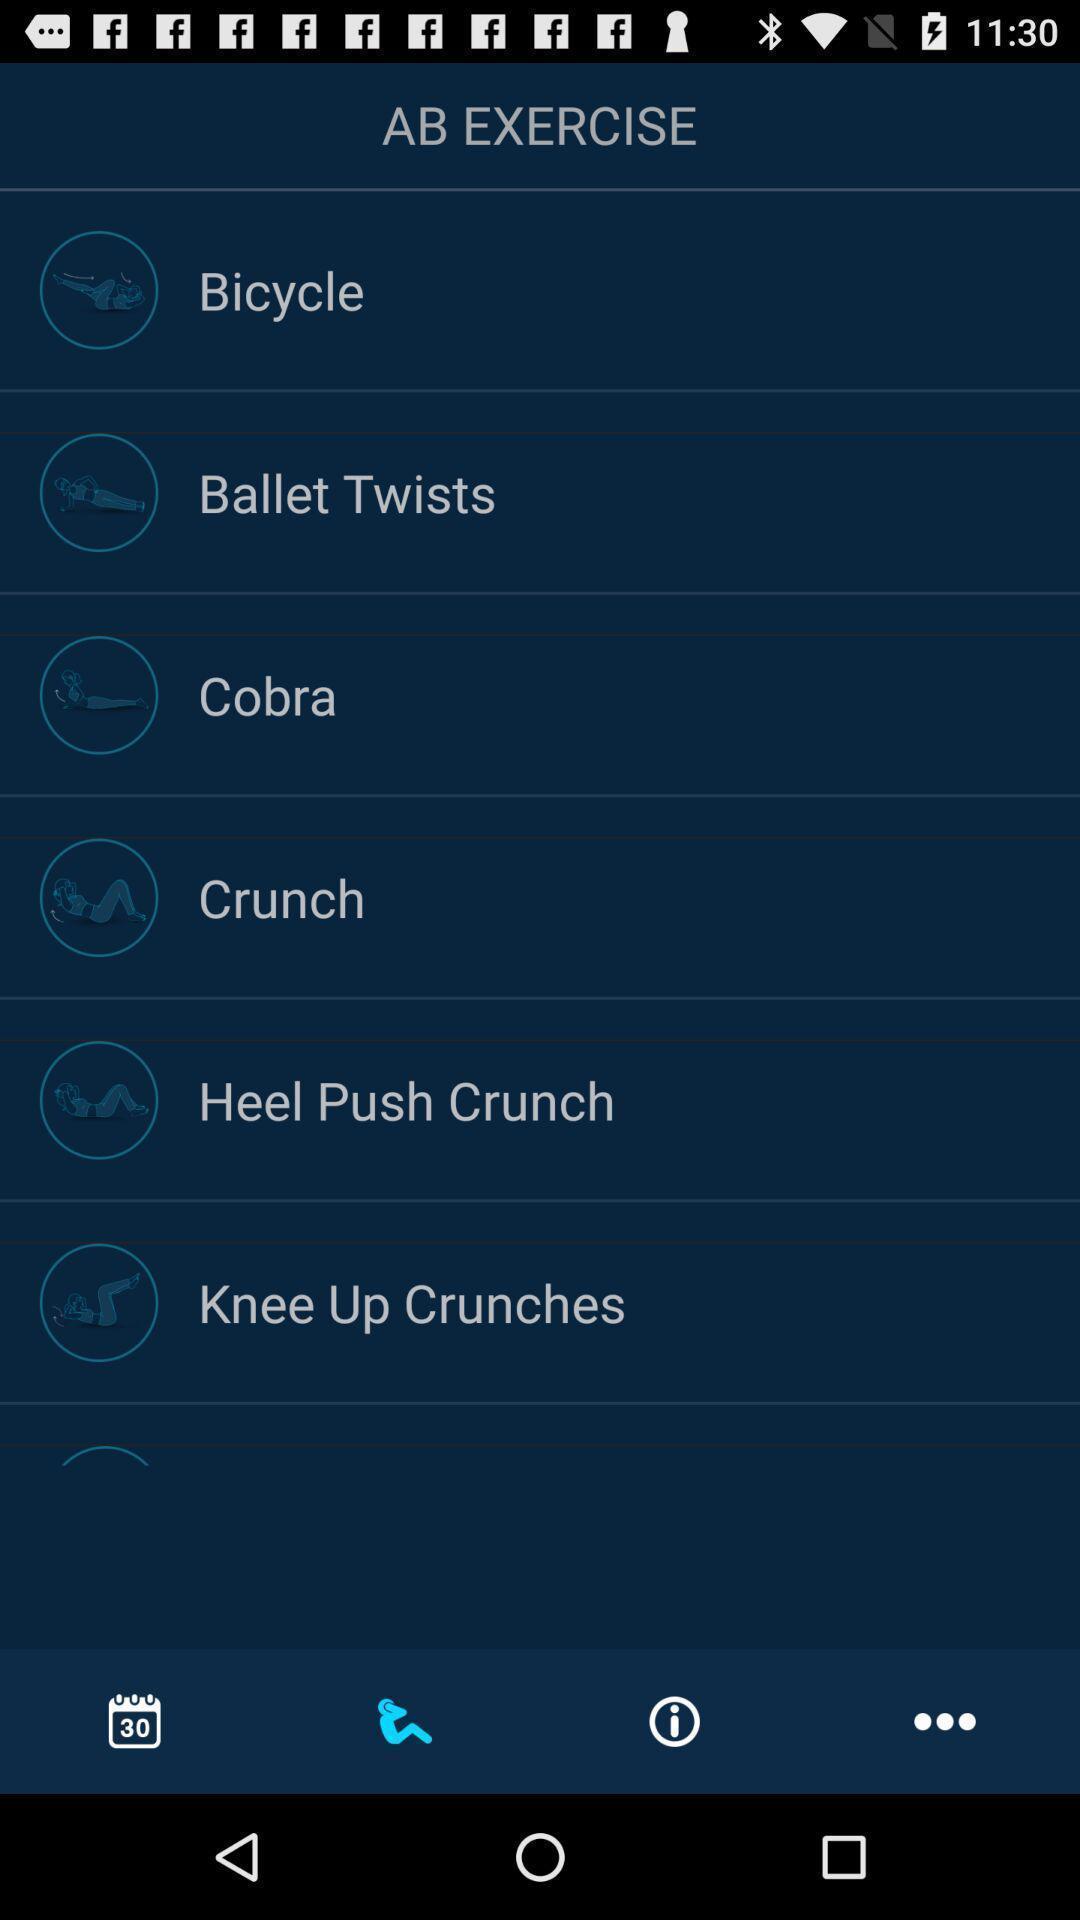Tell me about the visual elements in this screen capture. Screen page displaying various options in fitness app. 